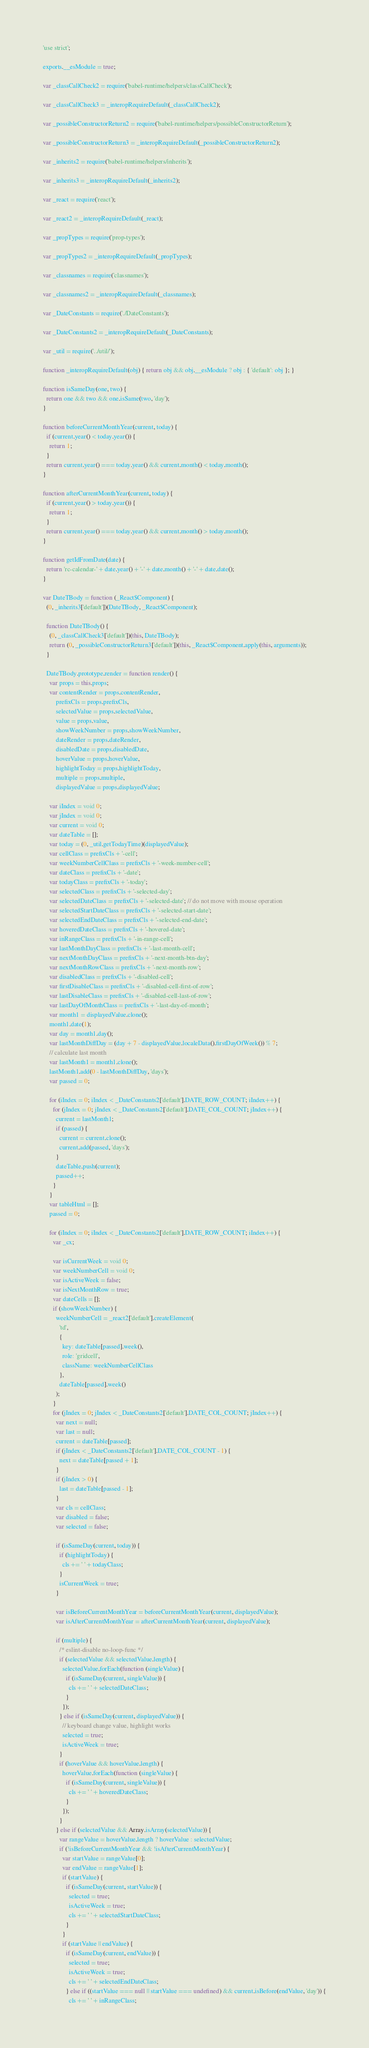<code> <loc_0><loc_0><loc_500><loc_500><_JavaScript_>'use strict';

exports.__esModule = true;

var _classCallCheck2 = require('babel-runtime/helpers/classCallCheck');

var _classCallCheck3 = _interopRequireDefault(_classCallCheck2);

var _possibleConstructorReturn2 = require('babel-runtime/helpers/possibleConstructorReturn');

var _possibleConstructorReturn3 = _interopRequireDefault(_possibleConstructorReturn2);

var _inherits2 = require('babel-runtime/helpers/inherits');

var _inherits3 = _interopRequireDefault(_inherits2);

var _react = require('react');

var _react2 = _interopRequireDefault(_react);

var _propTypes = require('prop-types');

var _propTypes2 = _interopRequireDefault(_propTypes);

var _classnames = require('classnames');

var _classnames2 = _interopRequireDefault(_classnames);

var _DateConstants = require('./DateConstants');

var _DateConstants2 = _interopRequireDefault(_DateConstants);

var _util = require('../util/');

function _interopRequireDefault(obj) { return obj && obj.__esModule ? obj : { 'default': obj }; }

function isSameDay(one, two) {
  return one && two && one.isSame(two, 'day');
}

function beforeCurrentMonthYear(current, today) {
  if (current.year() < today.year()) {
    return 1;
  }
  return current.year() === today.year() && current.month() < today.month();
}

function afterCurrentMonthYear(current, today) {
  if (current.year() > today.year()) {
    return 1;
  }
  return current.year() === today.year() && current.month() > today.month();
}

function getIdFromDate(date) {
  return 'rc-calendar-' + date.year() + '-' + date.month() + '-' + date.date();
}

var DateTBody = function (_React$Component) {
  (0, _inherits3['default'])(DateTBody, _React$Component);

  function DateTBody() {
    (0, _classCallCheck3['default'])(this, DateTBody);
    return (0, _possibleConstructorReturn3['default'])(this, _React$Component.apply(this, arguments));
  }

  DateTBody.prototype.render = function render() {
    var props = this.props;
    var contentRender = props.contentRender,
        prefixCls = props.prefixCls,
        selectedValue = props.selectedValue,
        value = props.value,
        showWeekNumber = props.showWeekNumber,
        dateRender = props.dateRender,
        disabledDate = props.disabledDate,
        hoverValue = props.hoverValue,
        highlightToday = props.highlightToday,
        multiple = props.multiple,
        displayedValue = props.displayedValue;

    var iIndex = void 0;
    var jIndex = void 0;
    var current = void 0;
    var dateTable = [];
    var today = (0, _util.getTodayTime)(displayedValue);
    var cellClass = prefixCls + '-cell';
    var weekNumberCellClass = prefixCls + '-week-number-cell';
    var dateClass = prefixCls + '-date';
    var todayClass = prefixCls + '-today';
    var selectedClass = prefixCls + '-selected-day';
    var selectedDateClass = prefixCls + '-selected-date'; // do not move with mouse operation
    var selectedStartDateClass = prefixCls + '-selected-start-date';
    var selectedEndDateClass = prefixCls + '-selected-end-date';
    var hoveredDateClass = prefixCls + '-hovered-date';
    var inRangeClass = prefixCls + '-in-range-cell';
    var lastMonthDayClass = prefixCls + '-last-month-cell';
    var nextMonthDayClass = prefixCls + '-next-month-btn-day';
    var nextMonthRowClass = prefixCls + '-next-month-row';
    var disabledClass = prefixCls + '-disabled-cell';
    var firstDisableClass = prefixCls + '-disabled-cell-first-of-row';
    var lastDisableClass = prefixCls + '-disabled-cell-last-of-row';
    var lastDayOfMonthClass = prefixCls + '-last-day-of-month';
    var month1 = displayedValue.clone();
    month1.date(1);
    var day = month1.day();
    var lastMonthDiffDay = (day + 7 - displayedValue.localeData().firstDayOfWeek()) % 7;
    // calculate last month
    var lastMonth1 = month1.clone();
    lastMonth1.add(0 - lastMonthDiffDay, 'days');
    var passed = 0;

    for (iIndex = 0; iIndex < _DateConstants2['default'].DATE_ROW_COUNT; iIndex++) {
      for (jIndex = 0; jIndex < _DateConstants2['default'].DATE_COL_COUNT; jIndex++) {
        current = lastMonth1;
        if (passed) {
          current = current.clone();
          current.add(passed, 'days');
        }
        dateTable.push(current);
        passed++;
      }
    }
    var tableHtml = [];
    passed = 0;

    for (iIndex = 0; iIndex < _DateConstants2['default'].DATE_ROW_COUNT; iIndex++) {
      var _cx;

      var isCurrentWeek = void 0;
      var weekNumberCell = void 0;
      var isActiveWeek = false;
      var isNextMonthRow = true;
      var dateCells = [];
      if (showWeekNumber) {
        weekNumberCell = _react2['default'].createElement(
          'td',
          {
            key: dateTable[passed].week(),
            role: 'gridcell',
            className: weekNumberCellClass
          },
          dateTable[passed].week()
        );
      }
      for (jIndex = 0; jIndex < _DateConstants2['default'].DATE_COL_COUNT; jIndex++) {
        var next = null;
        var last = null;
        current = dateTable[passed];
        if (jIndex < _DateConstants2['default'].DATE_COL_COUNT - 1) {
          next = dateTable[passed + 1];
        }
        if (jIndex > 0) {
          last = dateTable[passed - 1];
        }
        var cls = cellClass;
        var disabled = false;
        var selected = false;

        if (isSameDay(current, today)) {
          if (highlightToday) {
            cls += ' ' + todayClass;
          }
          isCurrentWeek = true;
        }

        var isBeforeCurrentMonthYear = beforeCurrentMonthYear(current, displayedValue);
        var isAfterCurrentMonthYear = afterCurrentMonthYear(current, displayedValue);

        if (multiple) {
          /* eslint-disable no-loop-func */
          if (selectedValue && selectedValue.length) {
            selectedValue.forEach(function (singleValue) {
              if (isSameDay(current, singleValue)) {
                cls += ' ' + selectedDateClass;
              }
            });
          } else if (isSameDay(current, displayedValue)) {
            // keyboard change value, highlight works
            selected = true;
            isActiveWeek = true;
          }
          if (hoverValue && hoverValue.length) {
            hoverValue.forEach(function (singleValue) {
              if (isSameDay(current, singleValue)) {
                cls += ' ' + hoveredDateClass;
              }
            });
          }
        } else if (selectedValue && Array.isArray(selectedValue)) {
          var rangeValue = hoverValue.length ? hoverValue : selectedValue;
          if (!isBeforeCurrentMonthYear && !isAfterCurrentMonthYear) {
            var startValue = rangeValue[0];
            var endValue = rangeValue[1];
            if (startValue) {
              if (isSameDay(current, startValue)) {
                selected = true;
                isActiveWeek = true;
                cls += ' ' + selectedStartDateClass;
              }
            }
            if (startValue || endValue) {
              if (isSameDay(current, endValue)) {
                selected = true;
                isActiveWeek = true;
                cls += ' ' + selectedEndDateClass;
              } else if ((startValue === null || startValue === undefined) && current.isBefore(endValue, 'day')) {
                cls += ' ' + inRangeClass;</code> 